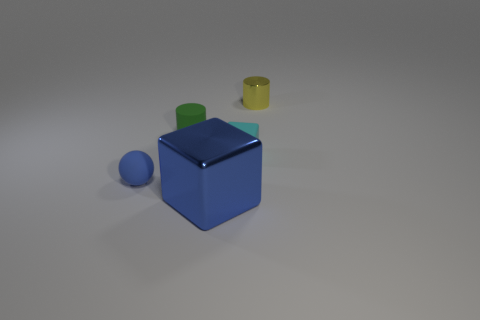How many things are either blue things that are to the right of the green matte object or cylinders to the left of the big blue metallic cube?
Your answer should be very brief. 2. Is the number of cyan rubber blocks that are left of the rubber cylinder the same as the number of small gray metal cylinders?
Ensure brevity in your answer.  Yes. Do the metal thing that is behind the small cyan object and the green rubber cylinder behind the small rubber cube have the same size?
Provide a succinct answer. Yes. How many other things are the same size as the blue metal object?
Keep it short and to the point. 0. There is a metal thing that is on the left side of the tiny cylinder to the right of the big shiny block; are there any balls right of it?
Ensure brevity in your answer.  No. Is there any other thing of the same color as the tiny cube?
Keep it short and to the point. No. What is the size of the block in front of the cyan rubber object?
Make the answer very short. Large. How big is the blue rubber ball behind the metal object in front of the blue object left of the shiny cube?
Your answer should be very brief. Small. What is the color of the cube on the right side of the metallic thing in front of the rubber cylinder?
Provide a short and direct response. Cyan. There is a large blue object that is the same shape as the tiny cyan matte thing; what is it made of?
Keep it short and to the point. Metal. 